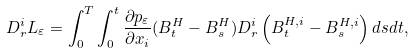<formula> <loc_0><loc_0><loc_500><loc_500>D _ { r } ^ { i } L _ { \varepsilon } = \int _ { 0 } ^ { T } \int _ { 0 } ^ { t } \frac { \partial p _ { \varepsilon } } { \partial x _ { i } } ( B _ { t } ^ { H } - B _ { s } ^ { H } ) D _ { r } ^ { i } \left ( B _ { t } ^ { H , i } - B _ { s } ^ { H , i } \right ) d s d t ,</formula> 